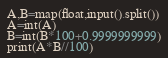Convert code to text. <code><loc_0><loc_0><loc_500><loc_500><_Python_>A,B=map(float,input().split())
A=int(A)
B=int(B*100+0.9999999999)
print(A*B//100)</code> 